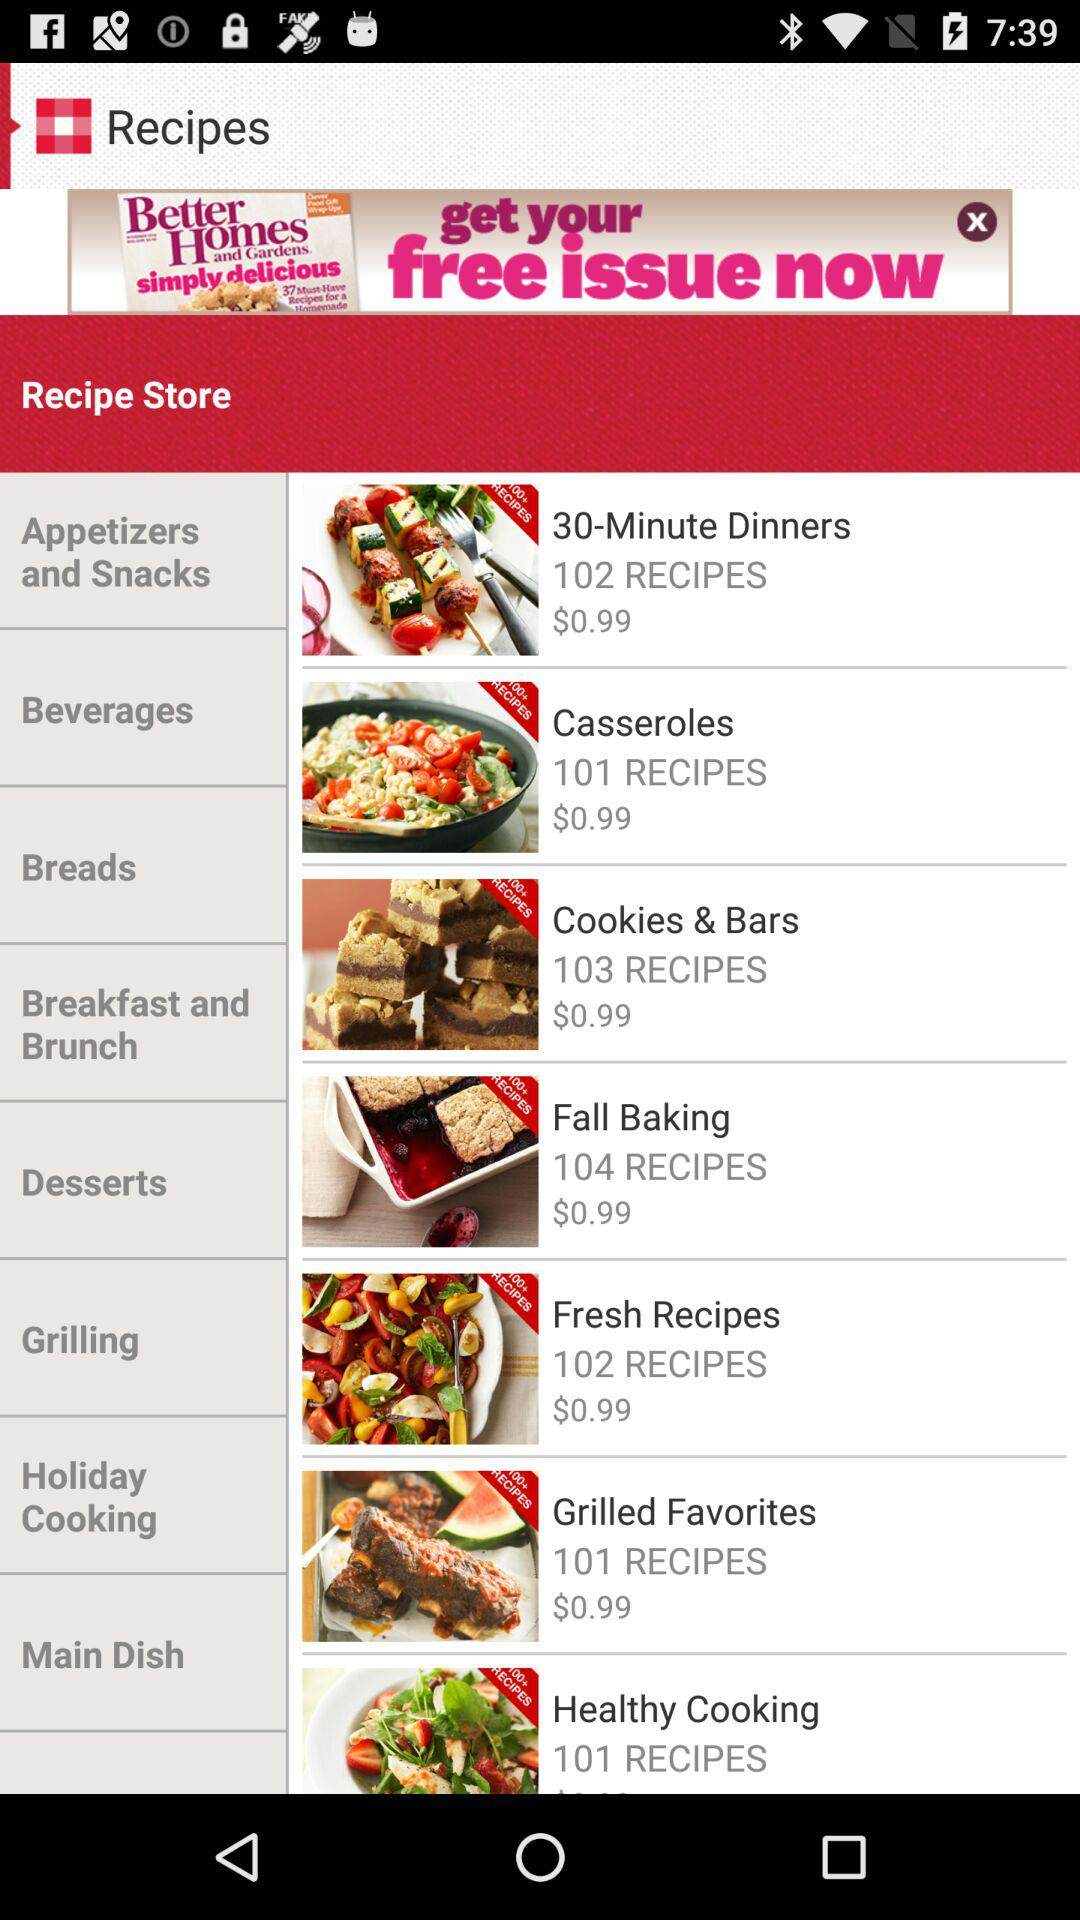How many recipes are there in "Fall Baking"? There are 104 recipes. 